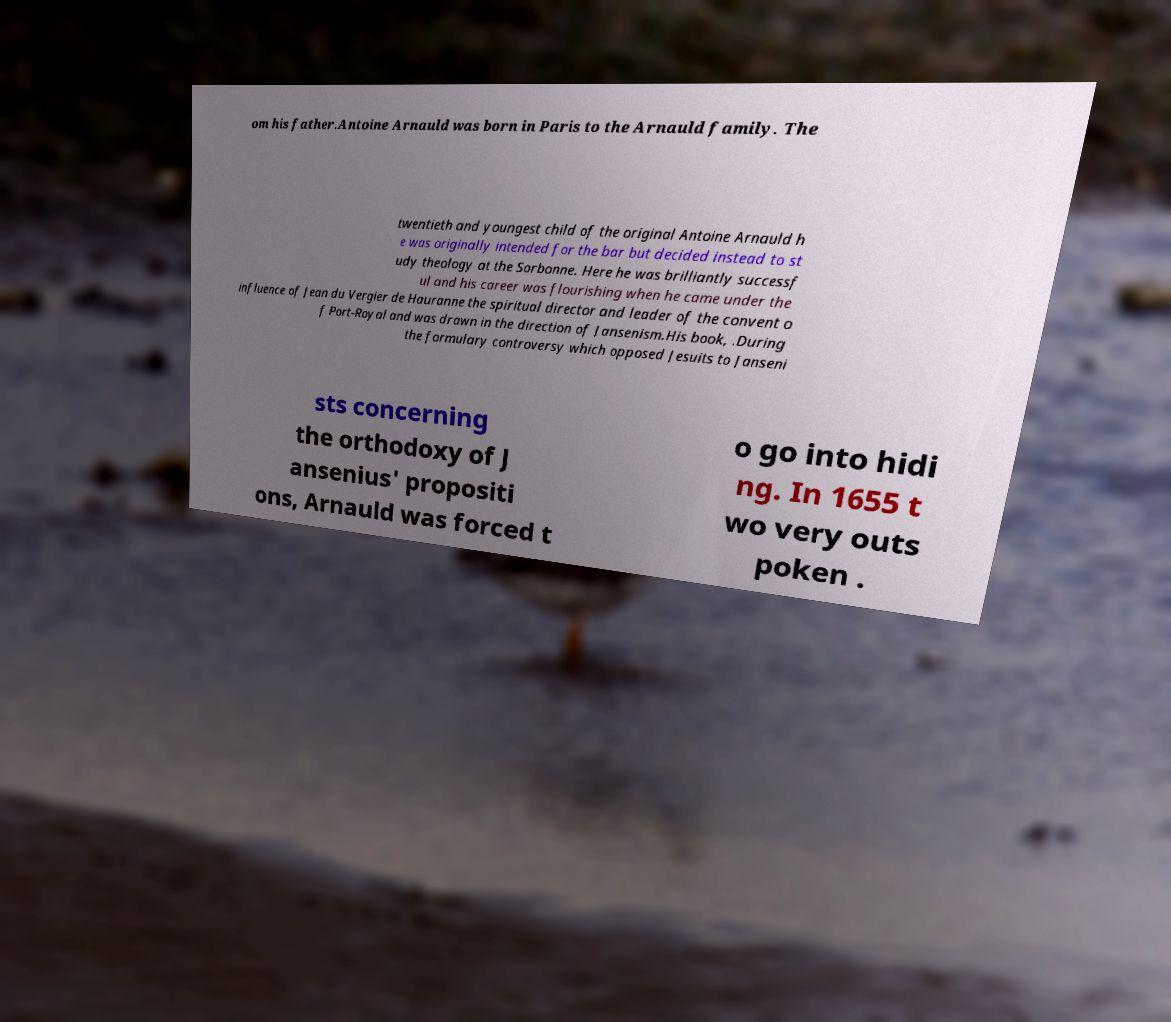Can you accurately transcribe the text from the provided image for me? om his father.Antoine Arnauld was born in Paris to the Arnauld family. The twentieth and youngest child of the original Antoine Arnauld h e was originally intended for the bar but decided instead to st udy theology at the Sorbonne. Here he was brilliantly successf ul and his career was flourishing when he came under the influence of Jean du Vergier de Hauranne the spiritual director and leader of the convent o f Port-Royal and was drawn in the direction of Jansenism.His book, .During the formulary controversy which opposed Jesuits to Janseni sts concerning the orthodoxy of J ansenius' propositi ons, Arnauld was forced t o go into hidi ng. In 1655 t wo very outs poken . 